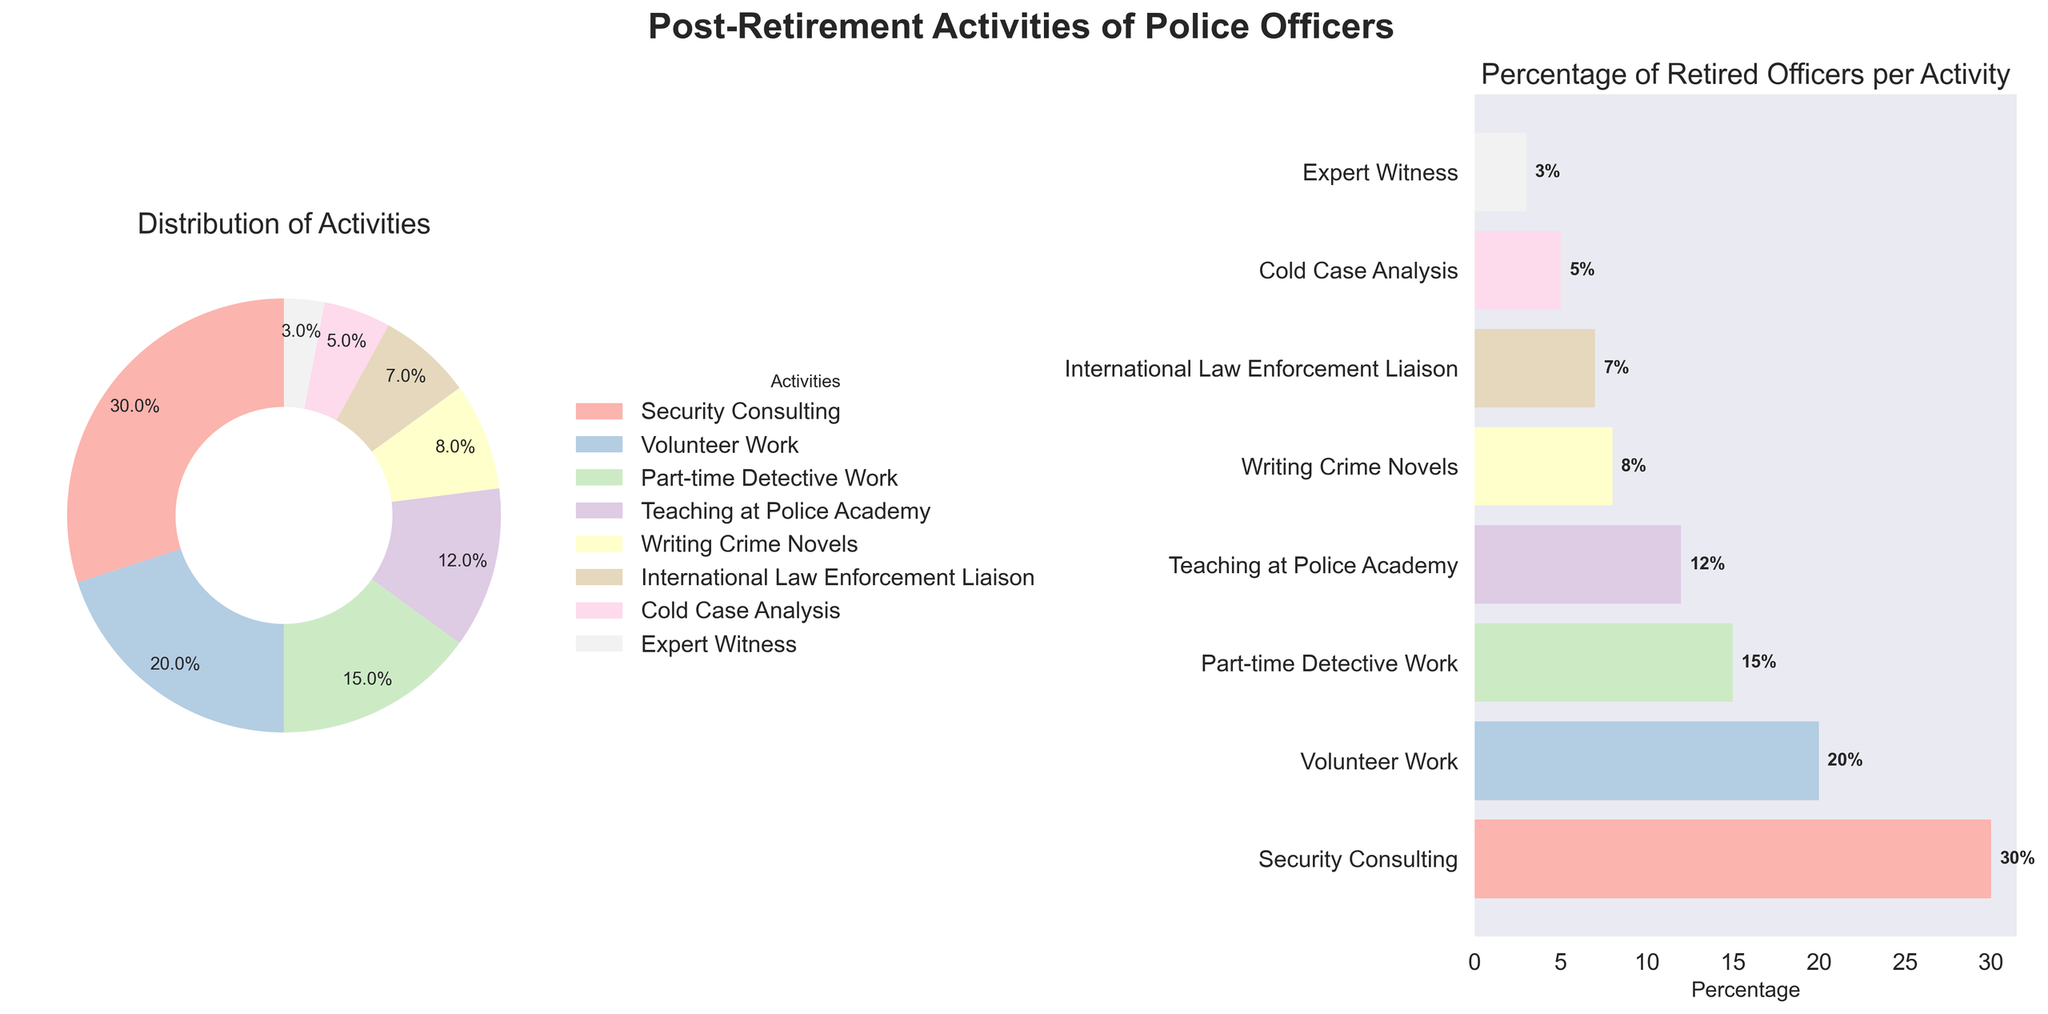Which activity has the highest percentage of retired police officers engaged in it? According to the pie chart, Security Consulting has the largest segment. The percentage shown next to it is 30%.
Answer: Security Consulting What is the title of the entire figure? The title of the figure is displayed at the top center in bold font. It reads 'Post-Retirement Activities of Police Officers'.
Answer: Post-Retirement Activities of Police Officers How many activities have a percentage greater than or equal to 10%? The activities with percentages greater than or equal to 10% are Security Consulting (30%), Volunteer Work (20%), Part-time Detective Work (15%), and Teaching at Police Academy (12%).
Answer: 4 What is the combined percentage of retired officers involved in Writing Crime Novels and Cold Case Analysis? The percentages for Writing Crime Novels and Cold Case Analysis are 8% and 5%, respectively. Adding them together, 8% + 5%, gives 13%.
Answer: 13% Which is the least common post-retirement activity according to the figure? The pie chart and bar chart show that the least common activity is Expert Witness, with a percentage of 3%.
Answer: Expert Witness Compare the percentage of retired officers involved in Volunteer Work to those in Part-time Detective Work. Which is higher and by how much? The percentage of Volunteer Work is 20%, while Part-time Detective Work is 15%. Subtracting these, we get 20% - 15% = 5%. So, Volunteer Work is higher by 5%.
Answer: Volunteer Work by 5% How many activities have less than 10% participation? From the bar chart, we observe that Writing Crime Novels (8%), International Law Enforcement Liaison (7%), Cold Case Analysis (5%), and Expert Witness (3%), all have less than 10% participation.
Answer: 4 How is the data presented in the second subplot? The second subplot shows a horizontal bar chart with activities on the y-axis and percentages on the x-axis. Bars are colored correspondingly to the segments in the pie chart.
Answer: Horizontal bar chart What can you infer about the popularity of Teaching at Police Academy compared to International Law Enforcement Liaison? The bar chart shows that Teaching at Police Academy (12%) has a higher percentage of participation compared to International Law Enforcement Liaison (7%), making it more popular.
Answer: Teaching at Police Academy is more popular What is the difference in percentage between the highest and the lowest activity? The highest activity is Security Consulting at 30%, and the lowest is Expert Witness at 3%. The difference is 30% - 3% = 27%.
Answer: 27% 